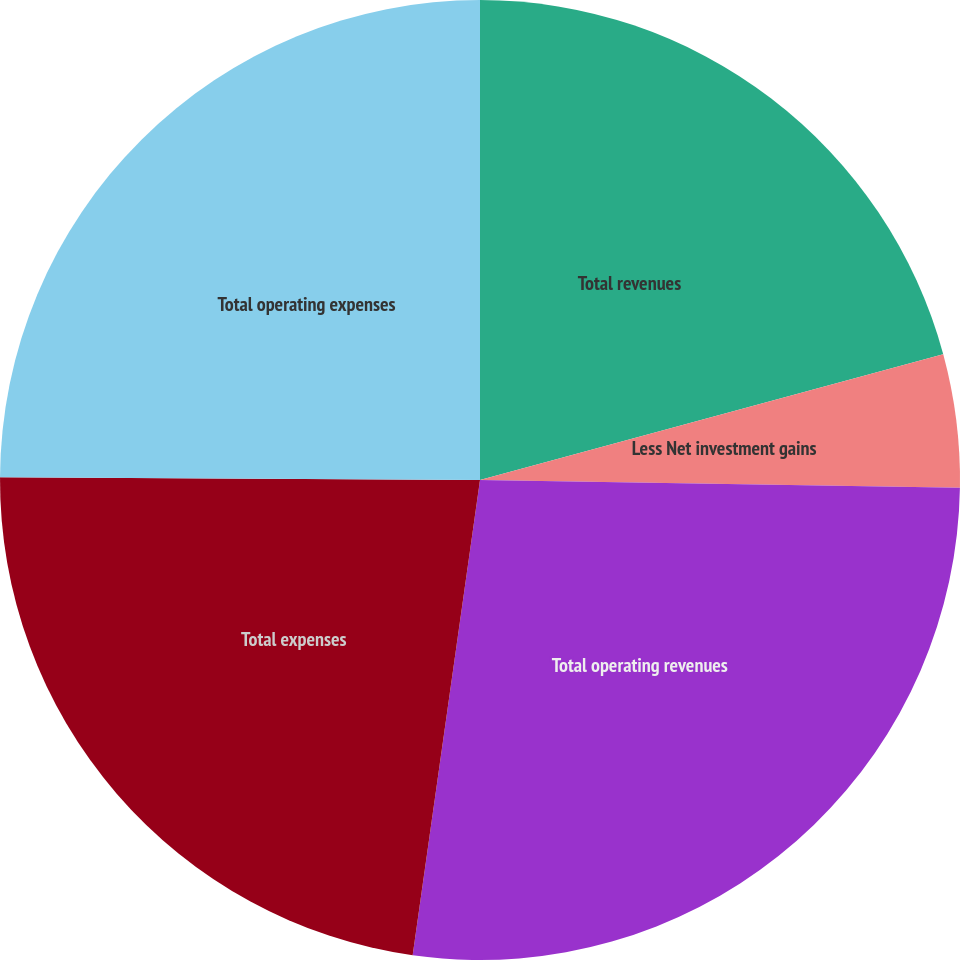Convert chart. <chart><loc_0><loc_0><loc_500><loc_500><pie_chart><fcel>Total revenues<fcel>Less Net investment gains<fcel>Total operating revenues<fcel>Total expenses<fcel>Total operating expenses<nl><fcel>20.78%<fcel>4.48%<fcel>26.98%<fcel>22.85%<fcel>24.91%<nl></chart> 